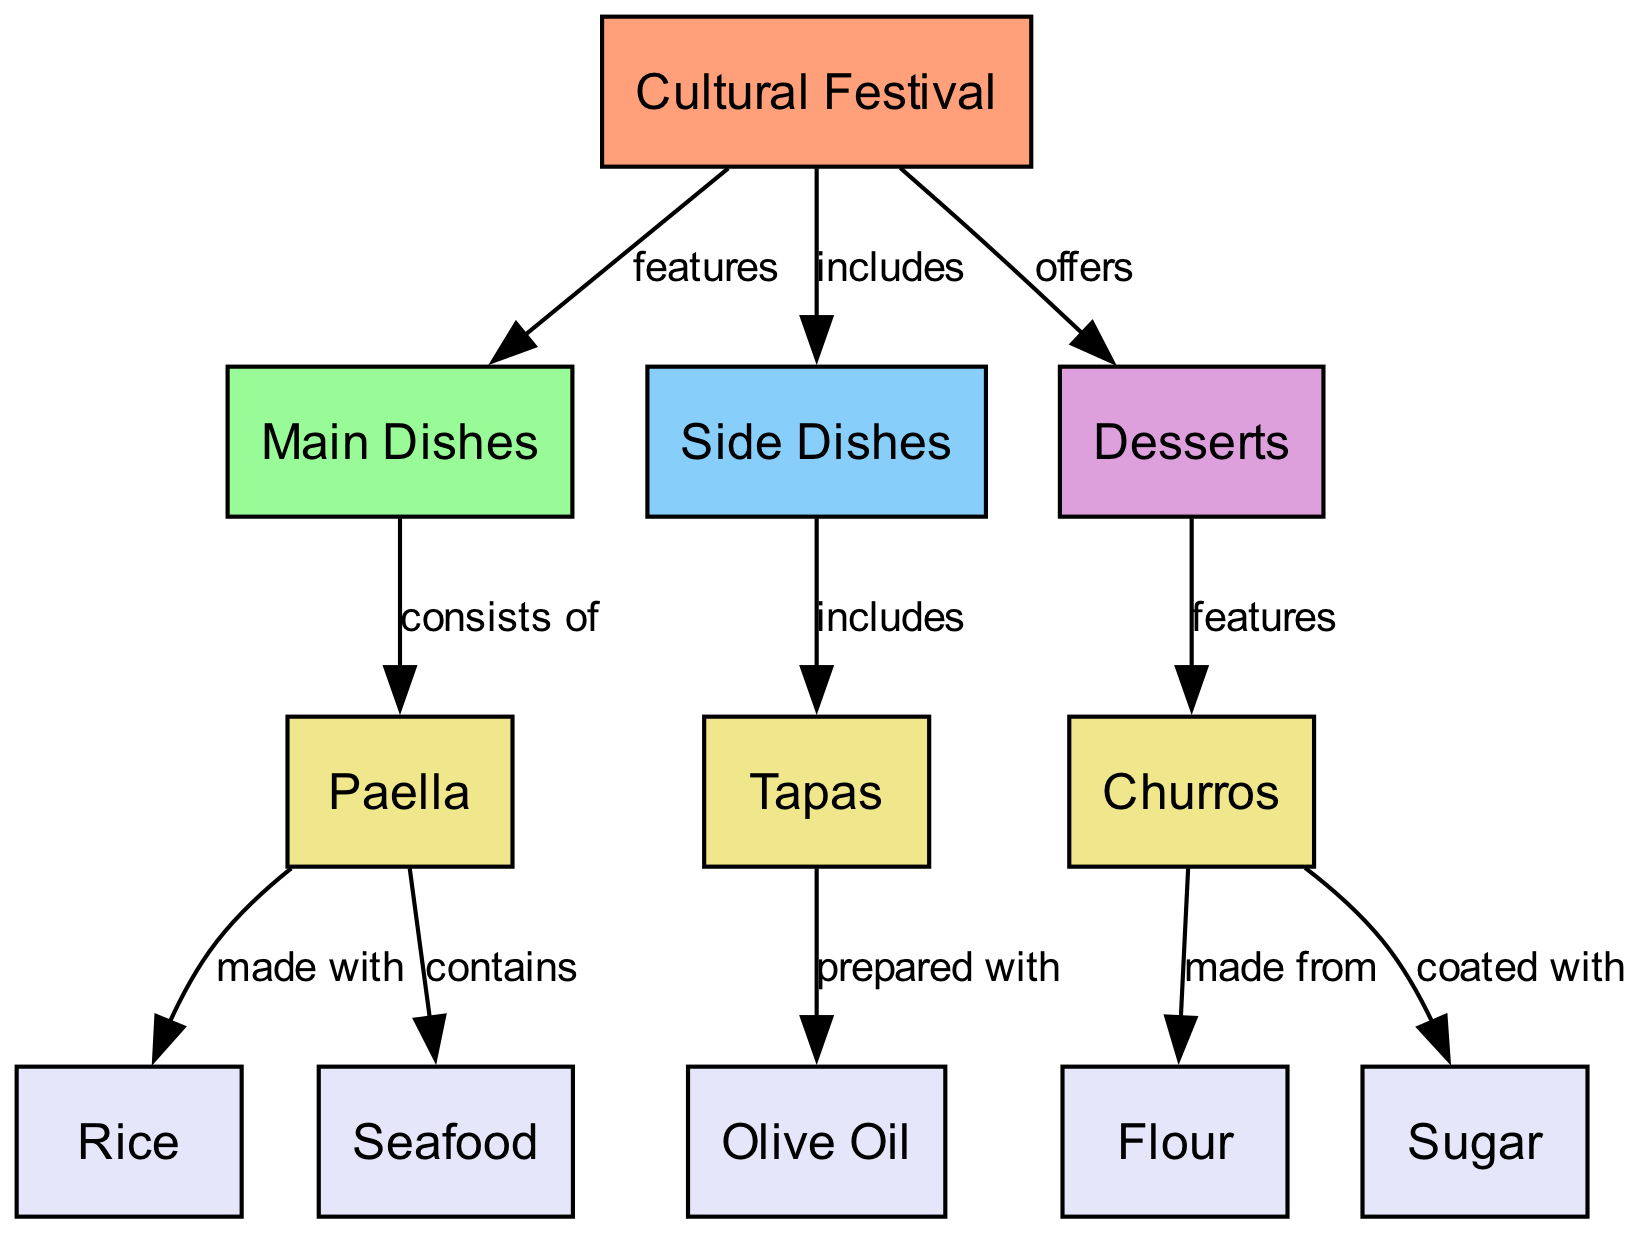What features does the cultural festival provide? The diagram indicates that the cultural festival features main dishes. Therefore, “main dishes” encapsulates the primary offerings of the festival.
Answer: main dishes How many main dishes are listed in the diagram? The diagram specifically mentions one main dish, which is paella. Hence, the count is derived from the information gathered from the node directly below "main dishes."
Answer: 1 What ingredients are used to make paella? According to the diagram, paella is made with rice and contains seafood. This indicates a direct relationship where rice is one ingredient while seafood is another.
Answer: rice, seafood What type of dish includes tapas? The diagram depicts that side dishes are the category that includes tapas. By referencing the hierarchy in the diagram, we can identify the relationship between side dishes and tapas.
Answer: side dishes Which dessert is featured in the cultural festival? The diagram explicitly states that churros are featured as the dessert in the cultural festival. This means churros are the designated dessert representative.
Answer: churros What ingredient is tapas prepared with? The diagram clearly shows that tapas is prepared with olive oil. This signifies that olive oil is an essential ingredient in the preparation of tapas.
Answer: olive oil What are churros made from? According to the diagram, churros are made from flour. This relationship indicates that flour is a critical ingredient in churros' composition.
Answer: flour What are churros coated with? The diagram illustrates that churros are coated with sugar. This relationship defines an essential step in the preparation of churros, specifying sugar as the coating ingredient.
Answer: sugar How many edges are there leading from the cultural festival to its offerings? The diagram indicates three different edges stemming from the cultural festival, pointing towards main dishes, side dishes, and desserts. These edges represent the relationships/offerings associated with the cultural festival.
Answer: 3 